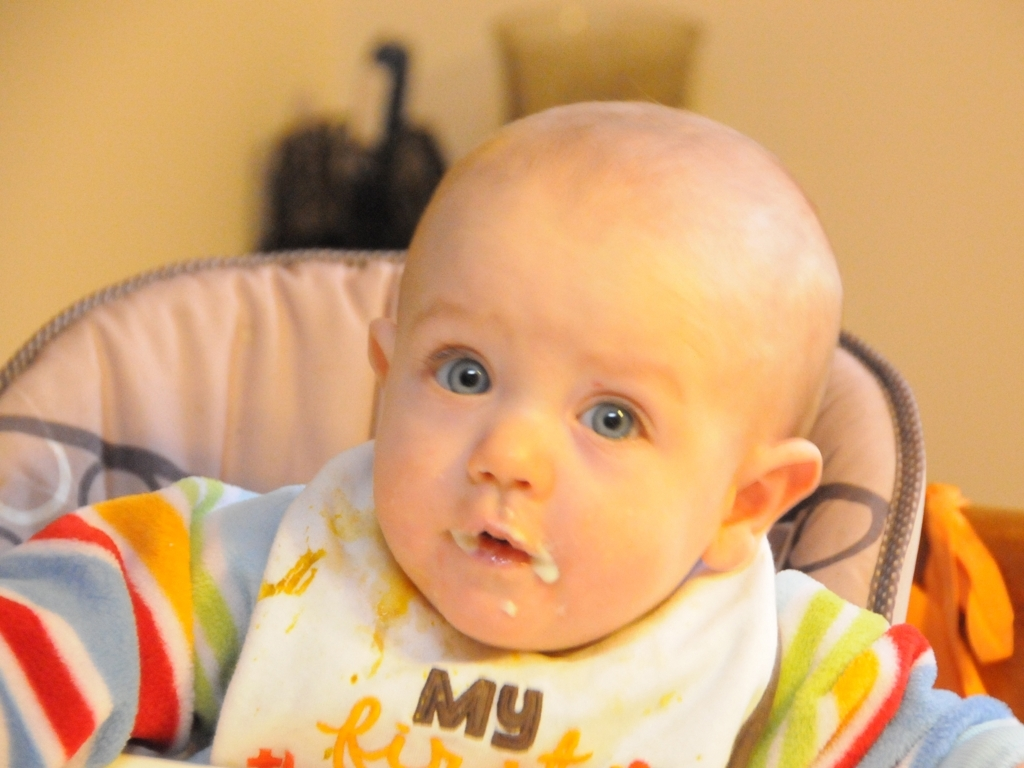Does the image have noise? While the image is relatively clear, upon closer inspection, there are some slight grainy textures present, which can be considered as minor noise. This could be due to the camera's sensitivity or the lighting conditions when the photo was taken. 